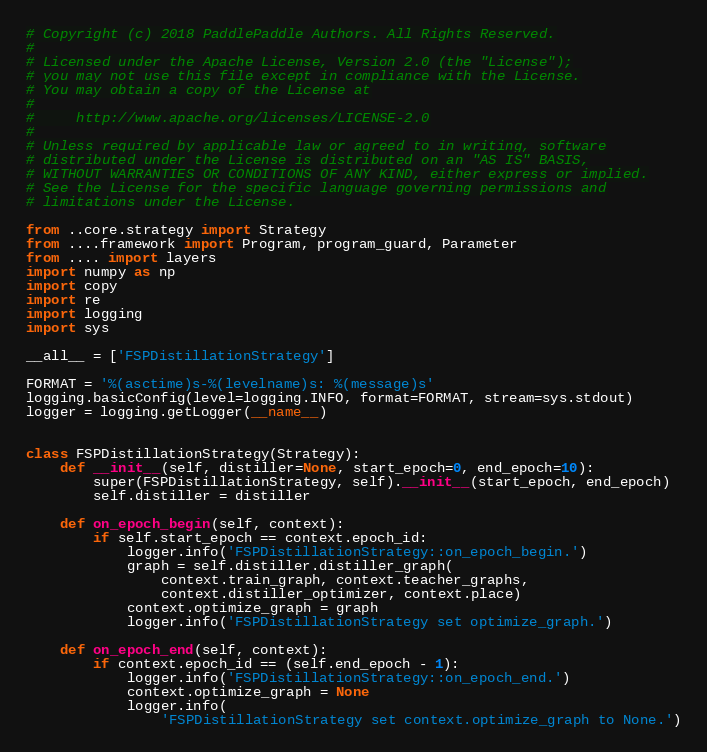<code> <loc_0><loc_0><loc_500><loc_500><_Python_># Copyright (c) 2018 PaddlePaddle Authors. All Rights Reserved.
#
# Licensed under the Apache License, Version 2.0 (the "License");
# you may not use this file except in compliance with the License.
# You may obtain a copy of the License at
#
#     http://www.apache.org/licenses/LICENSE-2.0
#
# Unless required by applicable law or agreed to in writing, software
# distributed under the License is distributed on an "AS IS" BASIS,
# WITHOUT WARRANTIES OR CONDITIONS OF ANY KIND, either express or implied.
# See the License for the specific language governing permissions and
# limitations under the License.

from ..core.strategy import Strategy
from ....framework import Program, program_guard, Parameter
from .... import layers
import numpy as np
import copy
import re
import logging
import sys

__all__ = ['FSPDistillationStrategy']

FORMAT = '%(asctime)s-%(levelname)s: %(message)s'
logging.basicConfig(level=logging.INFO, format=FORMAT, stream=sys.stdout)
logger = logging.getLogger(__name__)


class FSPDistillationStrategy(Strategy):
    def __init__(self, distiller=None, start_epoch=0, end_epoch=10):
        super(FSPDistillationStrategy, self).__init__(start_epoch, end_epoch)
        self.distiller = distiller

    def on_epoch_begin(self, context):
        if self.start_epoch == context.epoch_id:
            logger.info('FSPDistillationStrategy::on_epoch_begin.')
            graph = self.distiller.distiller_graph(
                context.train_graph, context.teacher_graphs,
                context.distiller_optimizer, context.place)
            context.optimize_graph = graph
            logger.info('FSPDistillationStrategy set optimize_graph.')

    def on_epoch_end(self, context):
        if context.epoch_id == (self.end_epoch - 1):
            logger.info('FSPDistillationStrategy::on_epoch_end.')
            context.optimize_graph = None
            logger.info(
                'FSPDistillationStrategy set context.optimize_graph to None.')
</code> 